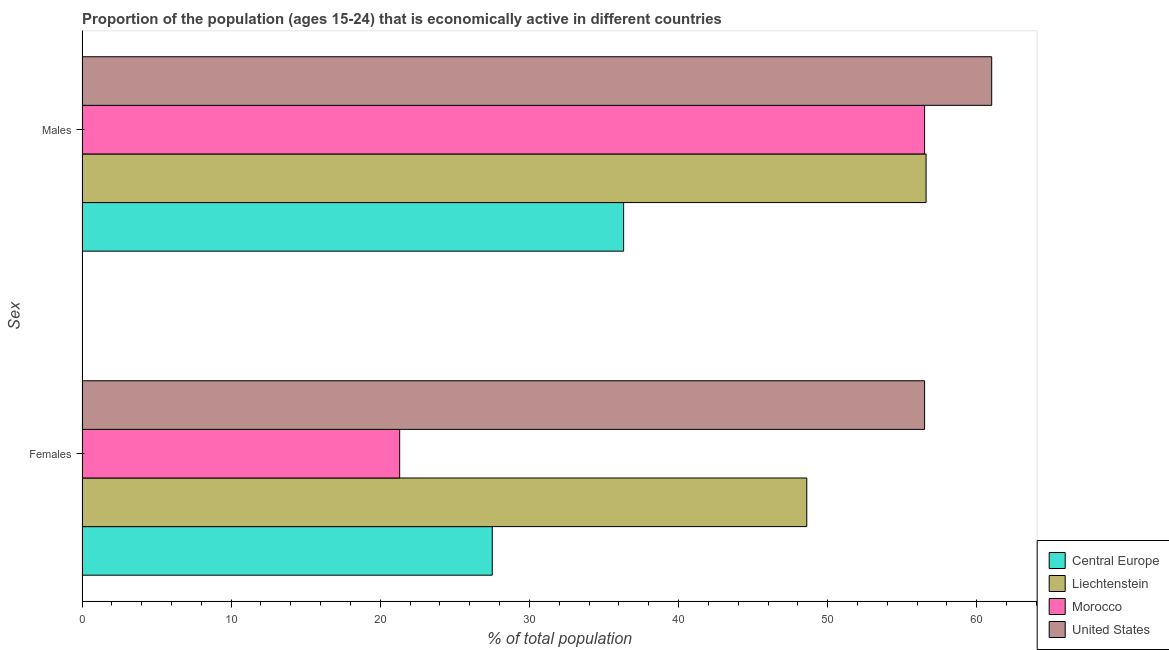How many different coloured bars are there?
Provide a short and direct response. 4. How many groups of bars are there?
Provide a succinct answer. 2. Are the number of bars per tick equal to the number of legend labels?
Provide a succinct answer. Yes. What is the label of the 2nd group of bars from the top?
Offer a very short reply. Females. What is the percentage of economically active male population in Liechtenstein?
Give a very brief answer. 56.6. Across all countries, what is the maximum percentage of economically active male population?
Provide a succinct answer. 61. Across all countries, what is the minimum percentage of economically active female population?
Offer a terse response. 21.3. In which country was the percentage of economically active female population maximum?
Give a very brief answer. United States. In which country was the percentage of economically active female population minimum?
Ensure brevity in your answer.  Morocco. What is the total percentage of economically active female population in the graph?
Provide a succinct answer. 153.91. What is the difference between the percentage of economically active female population in Liechtenstein and that in United States?
Offer a terse response. -7.9. What is the difference between the percentage of economically active female population in Morocco and the percentage of economically active male population in United States?
Provide a short and direct response. -39.7. What is the average percentage of economically active female population per country?
Make the answer very short. 38.48. What is the difference between the percentage of economically active male population and percentage of economically active female population in Liechtenstein?
Offer a terse response. 8. In how many countries, is the percentage of economically active female population greater than 14 %?
Ensure brevity in your answer.  4. What is the ratio of the percentage of economically active male population in United States to that in Liechtenstein?
Your answer should be very brief. 1.08. Is the percentage of economically active female population in Liechtenstein less than that in Central Europe?
Provide a succinct answer. No. In how many countries, is the percentage of economically active female population greater than the average percentage of economically active female population taken over all countries?
Give a very brief answer. 2. What does the 4th bar from the top in Females represents?
Ensure brevity in your answer.  Central Europe. What does the 3rd bar from the bottom in Males represents?
Keep it short and to the point. Morocco. What is the difference between two consecutive major ticks on the X-axis?
Keep it short and to the point. 10. Does the graph contain grids?
Make the answer very short. No. Where does the legend appear in the graph?
Give a very brief answer. Bottom right. What is the title of the graph?
Give a very brief answer. Proportion of the population (ages 15-24) that is economically active in different countries. Does "Nicaragua" appear as one of the legend labels in the graph?
Offer a terse response. No. What is the label or title of the X-axis?
Make the answer very short. % of total population. What is the label or title of the Y-axis?
Your response must be concise. Sex. What is the % of total population of Central Europe in Females?
Keep it short and to the point. 27.51. What is the % of total population of Liechtenstein in Females?
Ensure brevity in your answer.  48.6. What is the % of total population of Morocco in Females?
Your answer should be very brief. 21.3. What is the % of total population in United States in Females?
Your answer should be very brief. 56.5. What is the % of total population of Central Europe in Males?
Keep it short and to the point. 36.32. What is the % of total population in Liechtenstein in Males?
Keep it short and to the point. 56.6. What is the % of total population in Morocco in Males?
Keep it short and to the point. 56.5. Across all Sex, what is the maximum % of total population of Central Europe?
Offer a terse response. 36.32. Across all Sex, what is the maximum % of total population in Liechtenstein?
Your answer should be very brief. 56.6. Across all Sex, what is the maximum % of total population of Morocco?
Offer a terse response. 56.5. Across all Sex, what is the minimum % of total population in Central Europe?
Keep it short and to the point. 27.51. Across all Sex, what is the minimum % of total population in Liechtenstein?
Offer a very short reply. 48.6. Across all Sex, what is the minimum % of total population of Morocco?
Offer a very short reply. 21.3. Across all Sex, what is the minimum % of total population of United States?
Your answer should be compact. 56.5. What is the total % of total population in Central Europe in the graph?
Your answer should be very brief. 63.83. What is the total % of total population in Liechtenstein in the graph?
Your answer should be very brief. 105.2. What is the total % of total population in Morocco in the graph?
Provide a short and direct response. 77.8. What is the total % of total population in United States in the graph?
Your answer should be very brief. 117.5. What is the difference between the % of total population in Central Europe in Females and that in Males?
Provide a short and direct response. -8.81. What is the difference between the % of total population of Liechtenstein in Females and that in Males?
Ensure brevity in your answer.  -8. What is the difference between the % of total population in Morocco in Females and that in Males?
Offer a terse response. -35.2. What is the difference between the % of total population of United States in Females and that in Males?
Ensure brevity in your answer.  -4.5. What is the difference between the % of total population of Central Europe in Females and the % of total population of Liechtenstein in Males?
Provide a succinct answer. -29.09. What is the difference between the % of total population of Central Europe in Females and the % of total population of Morocco in Males?
Keep it short and to the point. -28.99. What is the difference between the % of total population of Central Europe in Females and the % of total population of United States in Males?
Provide a succinct answer. -33.49. What is the difference between the % of total population in Morocco in Females and the % of total population in United States in Males?
Provide a succinct answer. -39.7. What is the average % of total population in Central Europe per Sex?
Give a very brief answer. 31.91. What is the average % of total population of Liechtenstein per Sex?
Your answer should be very brief. 52.6. What is the average % of total population in Morocco per Sex?
Offer a terse response. 38.9. What is the average % of total population of United States per Sex?
Ensure brevity in your answer.  58.75. What is the difference between the % of total population in Central Europe and % of total population in Liechtenstein in Females?
Provide a short and direct response. -21.09. What is the difference between the % of total population of Central Europe and % of total population of Morocco in Females?
Your response must be concise. 6.21. What is the difference between the % of total population of Central Europe and % of total population of United States in Females?
Keep it short and to the point. -28.99. What is the difference between the % of total population of Liechtenstein and % of total population of Morocco in Females?
Provide a succinct answer. 27.3. What is the difference between the % of total population of Liechtenstein and % of total population of United States in Females?
Provide a succinct answer. -7.9. What is the difference between the % of total population in Morocco and % of total population in United States in Females?
Make the answer very short. -35.2. What is the difference between the % of total population in Central Europe and % of total population in Liechtenstein in Males?
Offer a very short reply. -20.28. What is the difference between the % of total population of Central Europe and % of total population of Morocco in Males?
Provide a short and direct response. -20.18. What is the difference between the % of total population of Central Europe and % of total population of United States in Males?
Make the answer very short. -24.68. What is the difference between the % of total population of Liechtenstein and % of total population of Morocco in Males?
Your response must be concise. 0.1. What is the difference between the % of total population of Liechtenstein and % of total population of United States in Males?
Provide a short and direct response. -4.4. What is the difference between the % of total population of Morocco and % of total population of United States in Males?
Ensure brevity in your answer.  -4.5. What is the ratio of the % of total population in Central Europe in Females to that in Males?
Provide a succinct answer. 0.76. What is the ratio of the % of total population of Liechtenstein in Females to that in Males?
Keep it short and to the point. 0.86. What is the ratio of the % of total population of Morocco in Females to that in Males?
Provide a short and direct response. 0.38. What is the ratio of the % of total population of United States in Females to that in Males?
Your answer should be very brief. 0.93. What is the difference between the highest and the second highest % of total population in Central Europe?
Keep it short and to the point. 8.81. What is the difference between the highest and the second highest % of total population of Liechtenstein?
Give a very brief answer. 8. What is the difference between the highest and the second highest % of total population of Morocco?
Ensure brevity in your answer.  35.2. What is the difference between the highest and the lowest % of total population in Central Europe?
Your response must be concise. 8.81. What is the difference between the highest and the lowest % of total population of Morocco?
Keep it short and to the point. 35.2. 